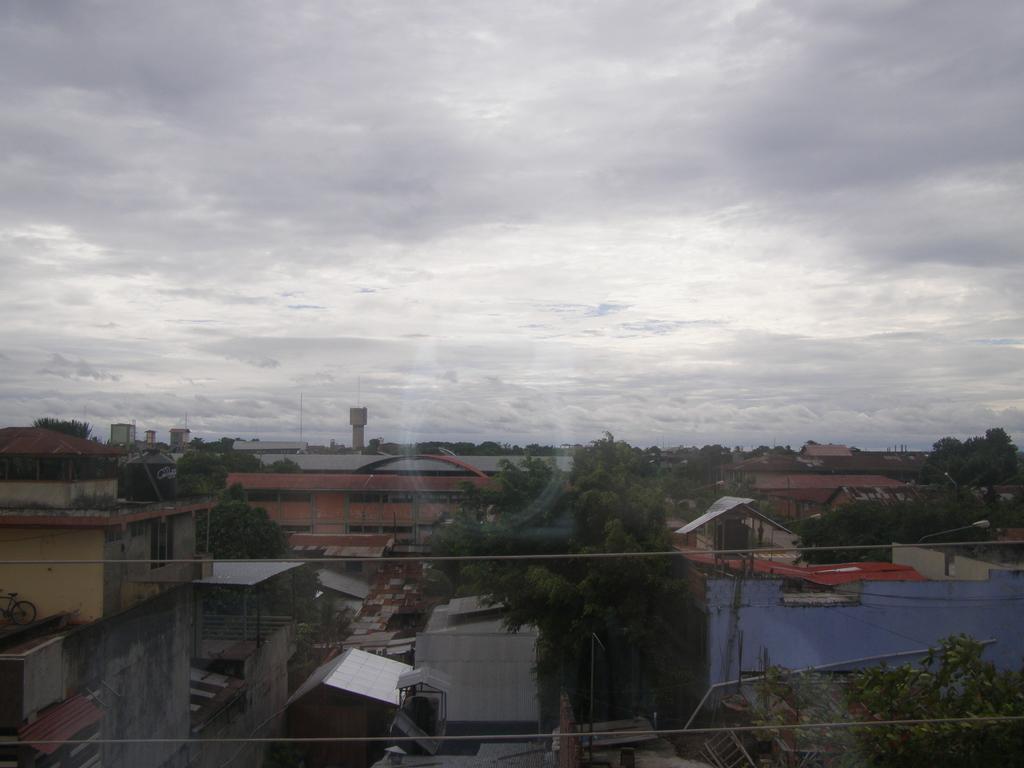Describe this image in one or two sentences. In the picture we can see a street with houses, buildings, trees, and some poles and in the background we can see a sky with clouds. 